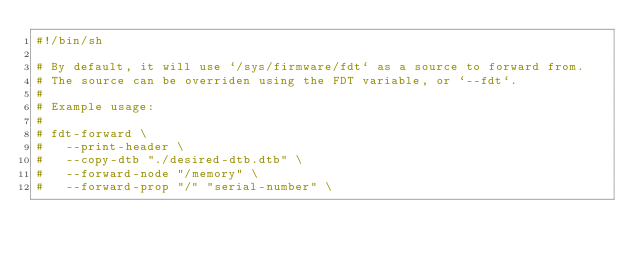<code> <loc_0><loc_0><loc_500><loc_500><_Bash_>#!/bin/sh

# By default, it will use `/sys/firmware/fdt` as a source to forward from.
# The source can be overriden using the FDT variable, or `--fdt`.
#
# Example usage:
#
# fdt-forward \
#	--print-header \
#	--copy-dtb "./desired-dtb.dtb" \
#	--forward-node "/memory" \
#	--forward-prop "/" "serial-number" \</code> 